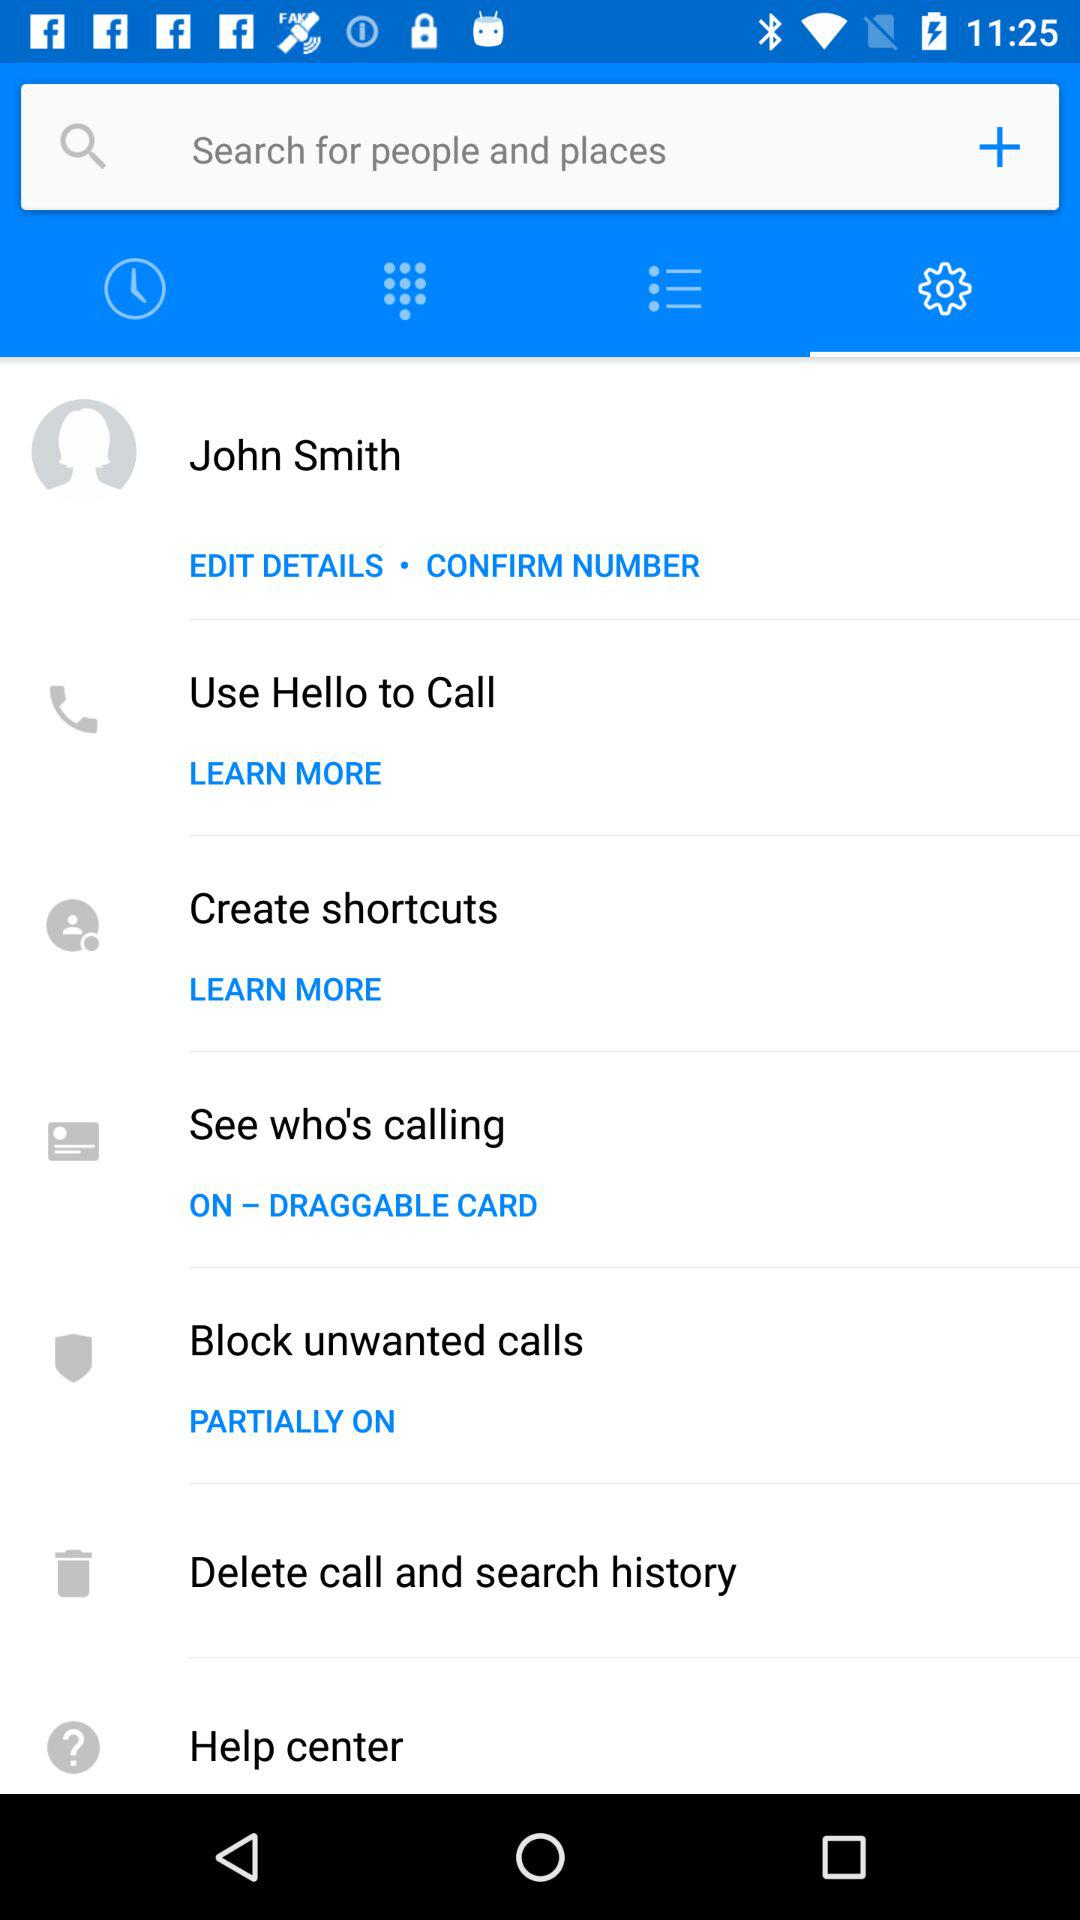What is the user name? The user name is John Smith. 